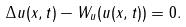<formula> <loc_0><loc_0><loc_500><loc_500>\Delta u ( x , t ) - W _ { u } ( u ( x , t ) ) = 0 .</formula> 